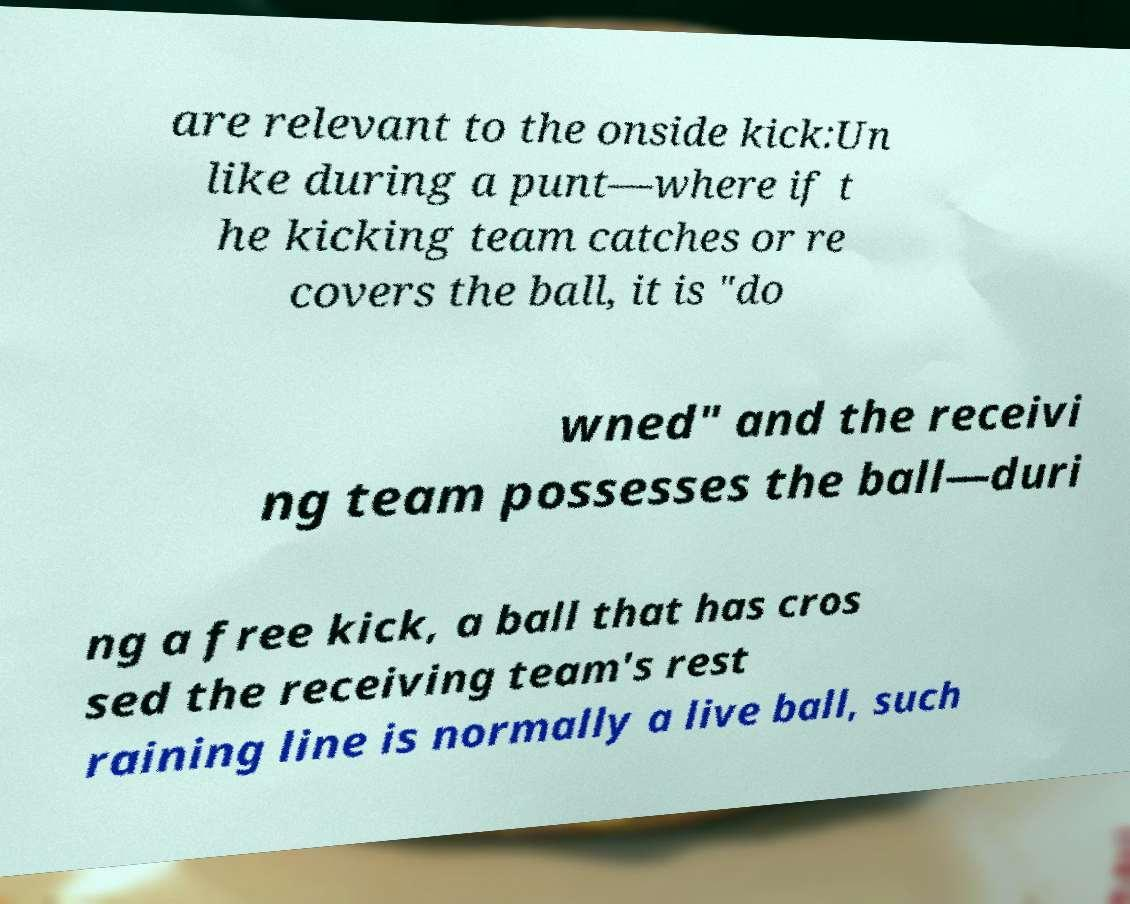What messages or text are displayed in this image? I need them in a readable, typed format. are relevant to the onside kick:Un like during a punt—where if t he kicking team catches or re covers the ball, it is "do wned" and the receivi ng team possesses the ball—duri ng a free kick, a ball that has cros sed the receiving team's rest raining line is normally a live ball, such 